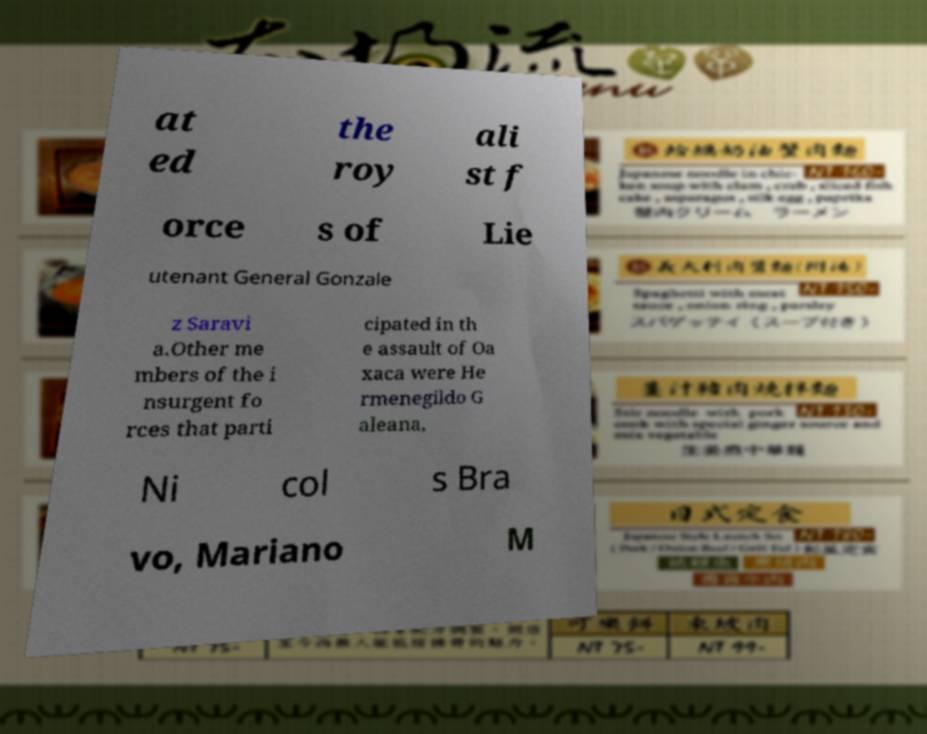There's text embedded in this image that I need extracted. Can you transcribe it verbatim? at ed the roy ali st f orce s of Lie utenant General Gonzale z Saravi a.Other me mbers of the i nsurgent fo rces that parti cipated in th e assault of Oa xaca were He rmenegildo G aleana, Ni col s Bra vo, Mariano M 